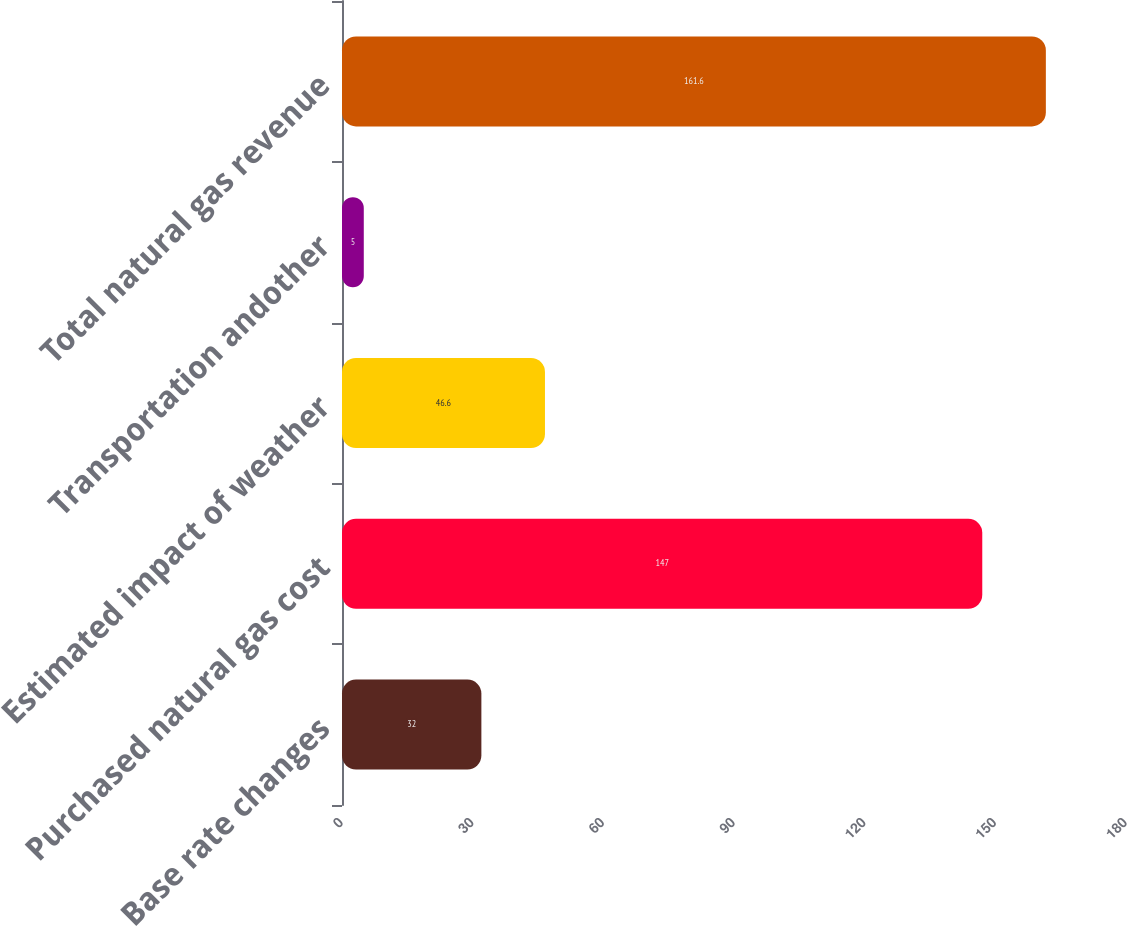<chart> <loc_0><loc_0><loc_500><loc_500><bar_chart><fcel>Base rate changes<fcel>Purchased natural gas cost<fcel>Estimated impact of weather<fcel>Transportation andother<fcel>Total natural gas revenue<nl><fcel>32<fcel>147<fcel>46.6<fcel>5<fcel>161.6<nl></chart> 